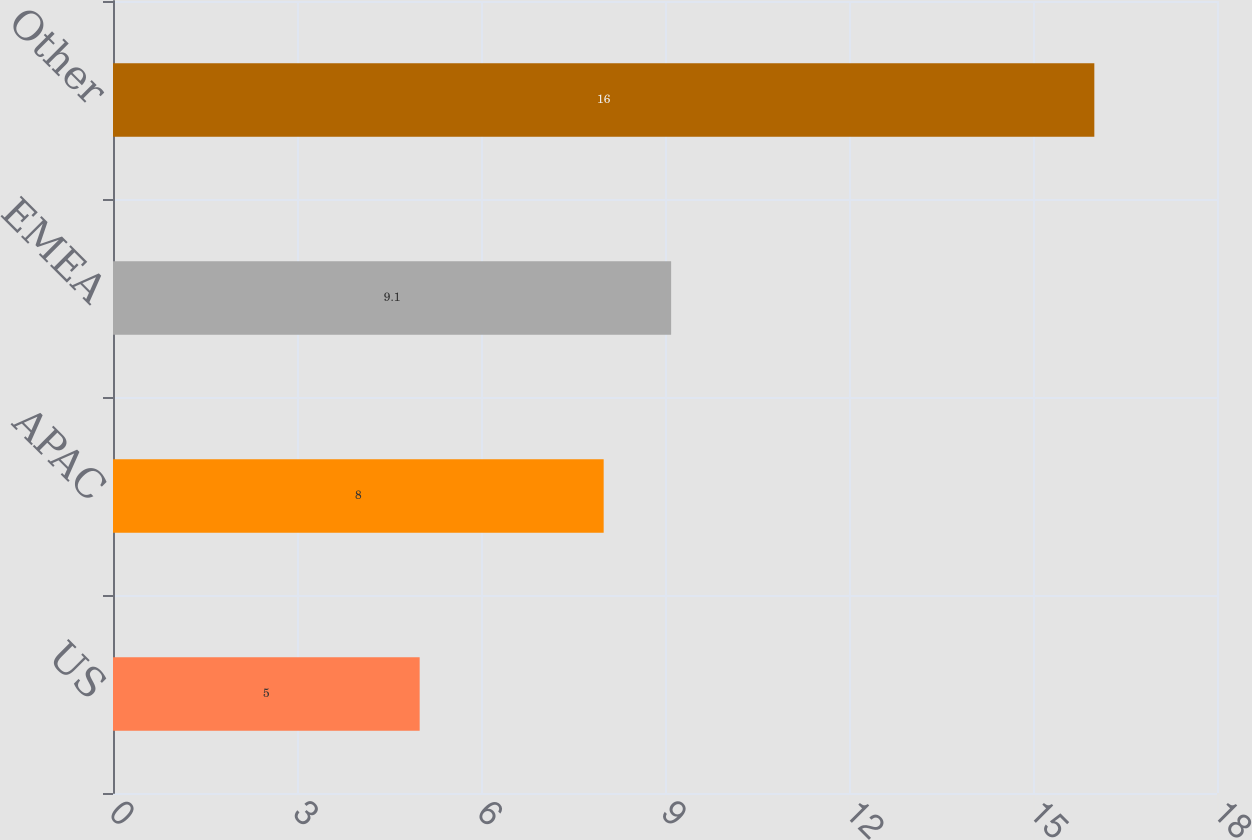Convert chart to OTSL. <chart><loc_0><loc_0><loc_500><loc_500><bar_chart><fcel>US<fcel>APAC<fcel>EMEA<fcel>Other<nl><fcel>5<fcel>8<fcel>9.1<fcel>16<nl></chart> 